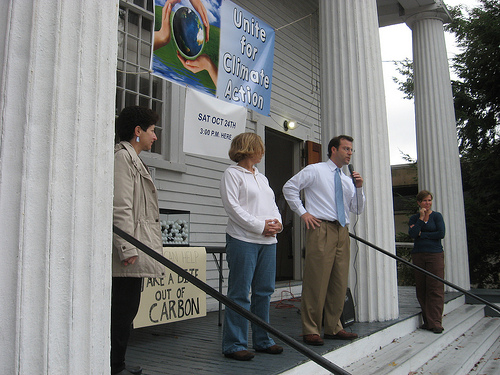<image>
Can you confirm if the man is to the right of the woman? Yes. From this viewpoint, the man is positioned to the right side relative to the woman. 